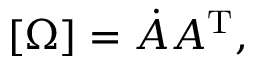Convert formula to latex. <formula><loc_0><loc_0><loc_500><loc_500>[ \Omega ] = { \dot { A } } A ^ { T } ,</formula> 